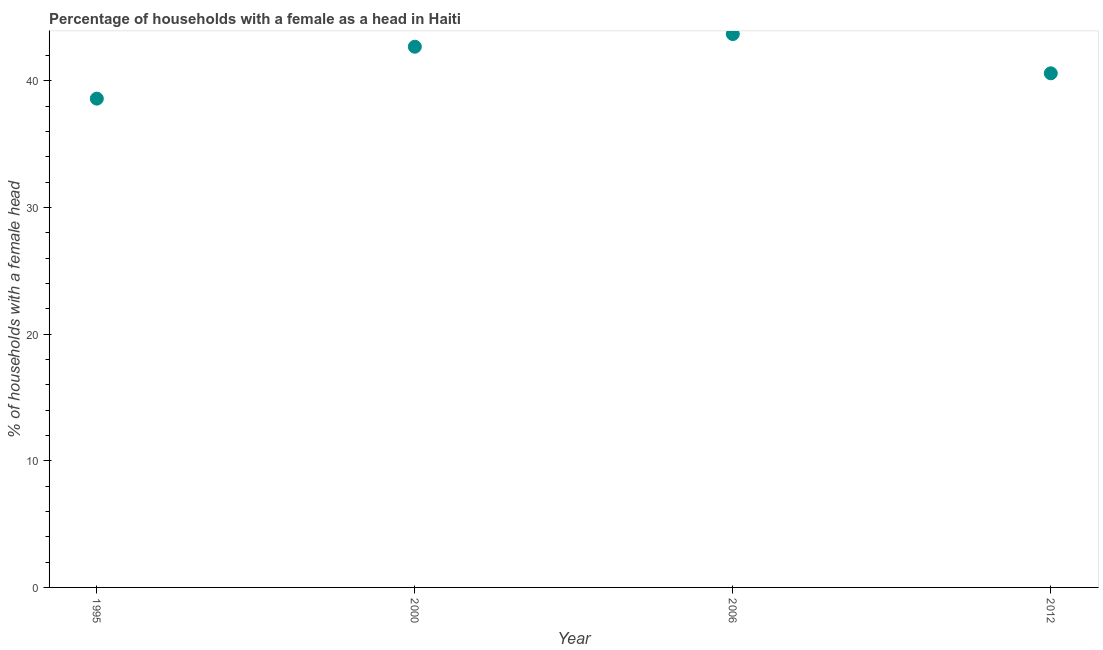What is the number of female supervised households in 2006?
Provide a short and direct response. 43.7. Across all years, what is the maximum number of female supervised households?
Provide a succinct answer. 43.7. Across all years, what is the minimum number of female supervised households?
Your response must be concise. 38.6. What is the sum of the number of female supervised households?
Your answer should be very brief. 165.6. What is the average number of female supervised households per year?
Offer a terse response. 41.4. What is the median number of female supervised households?
Ensure brevity in your answer.  41.65. In how many years, is the number of female supervised households greater than 36 %?
Offer a terse response. 4. What is the ratio of the number of female supervised households in 1995 to that in 2012?
Your response must be concise. 0.95. What is the difference between the highest and the lowest number of female supervised households?
Offer a terse response. 5.1. Does the number of female supervised households monotonically increase over the years?
Provide a succinct answer. No. What is the difference between two consecutive major ticks on the Y-axis?
Your response must be concise. 10. Are the values on the major ticks of Y-axis written in scientific E-notation?
Keep it short and to the point. No. Does the graph contain grids?
Make the answer very short. No. What is the title of the graph?
Your answer should be very brief. Percentage of households with a female as a head in Haiti. What is the label or title of the Y-axis?
Offer a very short reply. % of households with a female head. What is the % of households with a female head in 1995?
Keep it short and to the point. 38.6. What is the % of households with a female head in 2000?
Ensure brevity in your answer.  42.7. What is the % of households with a female head in 2006?
Offer a very short reply. 43.7. What is the % of households with a female head in 2012?
Offer a very short reply. 40.6. What is the difference between the % of households with a female head in 1995 and 2000?
Provide a succinct answer. -4.1. What is the difference between the % of households with a female head in 1995 and 2006?
Offer a terse response. -5.1. What is the difference between the % of households with a female head in 1995 and 2012?
Your answer should be compact. -2. What is the difference between the % of households with a female head in 2000 and 2012?
Your answer should be compact. 2.1. What is the ratio of the % of households with a female head in 1995 to that in 2000?
Your answer should be compact. 0.9. What is the ratio of the % of households with a female head in 1995 to that in 2006?
Your answer should be very brief. 0.88. What is the ratio of the % of households with a female head in 1995 to that in 2012?
Provide a succinct answer. 0.95. What is the ratio of the % of households with a female head in 2000 to that in 2012?
Your response must be concise. 1.05. What is the ratio of the % of households with a female head in 2006 to that in 2012?
Your answer should be compact. 1.08. 